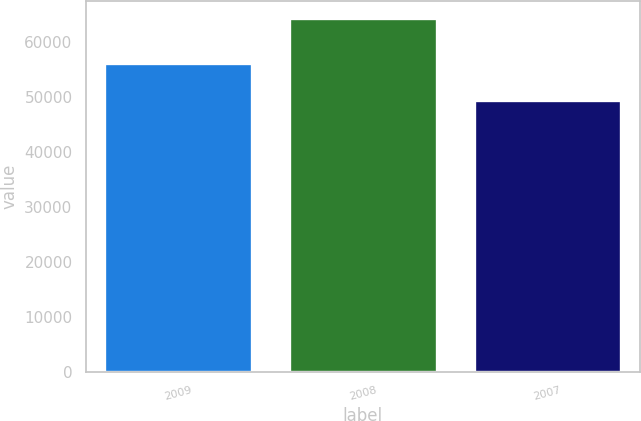Convert chart. <chart><loc_0><loc_0><loc_500><loc_500><bar_chart><fcel>2009<fcel>2008<fcel>2007<nl><fcel>56103<fcel>64239<fcel>49401<nl></chart> 